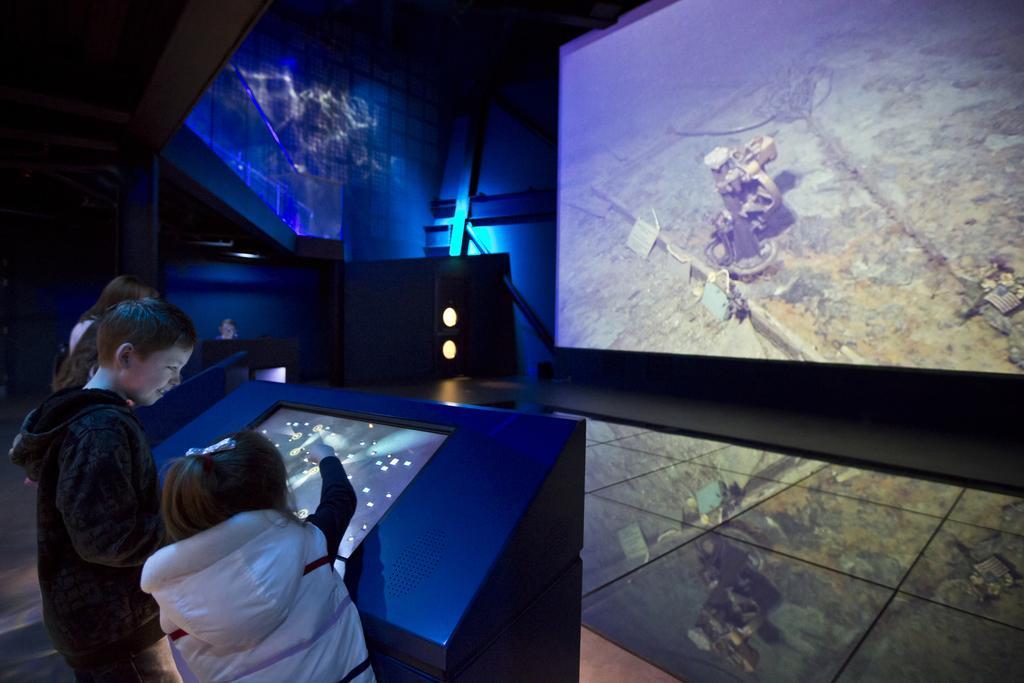Please provide a concise description of this image. In this picture we can see some persons standing on the floor and in front of them we can see screens, lights and in the background we can see wall. 